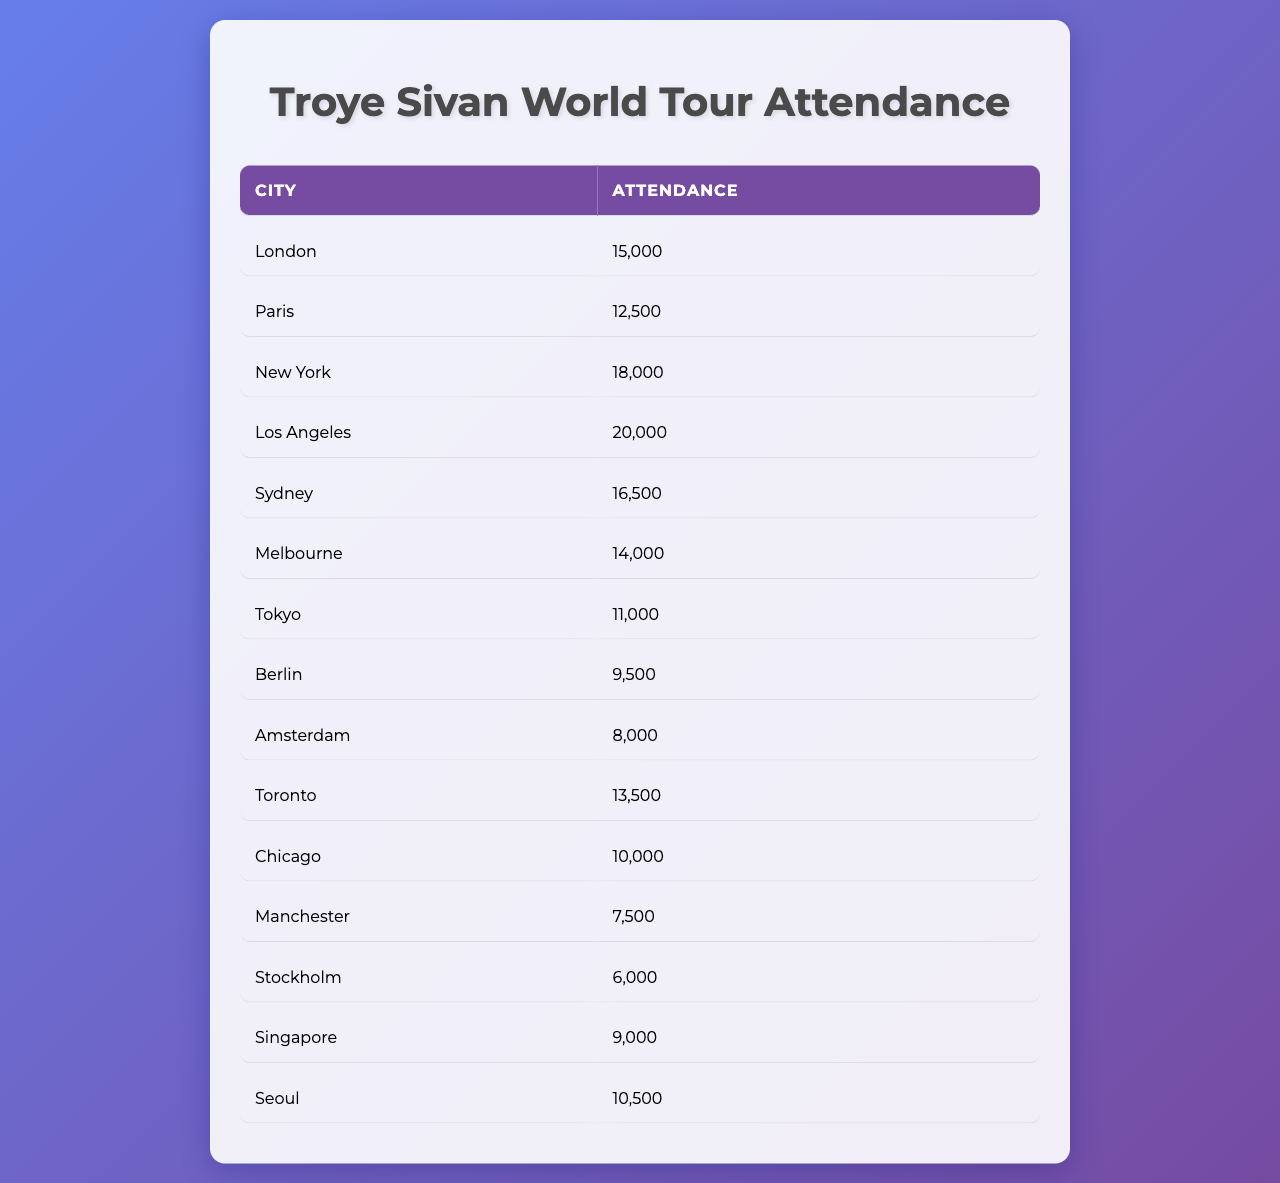What is the highest attendance recorded and in which city? The highest attendance is 20,000, which is recorded in Los Angeles, as noted in the attendance column next to the city name.
Answer: 20,000 in Los Angeles Which city had the lowest attendance? The lowest attendance listed in the table is 6,000, which corresponds to the city of Stockholm.
Answer: Stockholm What is the total attendance across all cities? To find the total attendance, we sum all the attendance figures: 15000 + 12500 + 18000 + 20000 + 16500 + 14000 + 11000 + 9500 + 8000 + 13500 + 10000 + 7500 + 6000 + 9000 + 10500 = 149500.
Answer: 149,500 What is the difference in attendance between New York and Tokyo? New York has an attendance of 18,000 while Tokyo has 11,000. The difference is calculated as 18,000 - 11,000, which equals 7,000.
Answer: 7,000 Is the attendance in Melbourne greater than in Amsterdam? Melbourne's attendance is 14,000 and Amsterdam's is 8,000, thus Melbourne does have greater attendance, confirming the statement is true.
Answer: Yes What is the average attendance of all concerts? To find the average attendance, sum all the attendance numbers (149,500) and divide by the number of cities (15): 149,500 / 15 = 9,966.67.
Answer: 9,966.67 Which city had an attendance greater than 15,000? The cities with attendance above 15,000 are London (15,000), New York (18,000), Los Angeles (20,000), Sydney (16,500).
Answer: London, New York, Los Angeles, Sydney Which city had an attendance that is 1,000 less than Chicago? Chicago's attendance is 10,000; hence, the city with an attendance of 9,000 is Seoul, which is 1,000 less than Chicago.
Answer: Seoul Calculate the attendance variance between the cities with the highest and lowest attendance. The highest attendance is 20,000 (Los Angeles) and the lowest is 6,000 (Stockholm). The variance is 20,000 - 6,000 = 14,000.
Answer: 14,000 Are there any cities with attendance between 10,000 and 15,000? Yes, the cities with attendance between 10,000 and 15,000 are Melbourne (14,000), Toronto (13,500), and Chicago (10,000).
Answer: Yes 